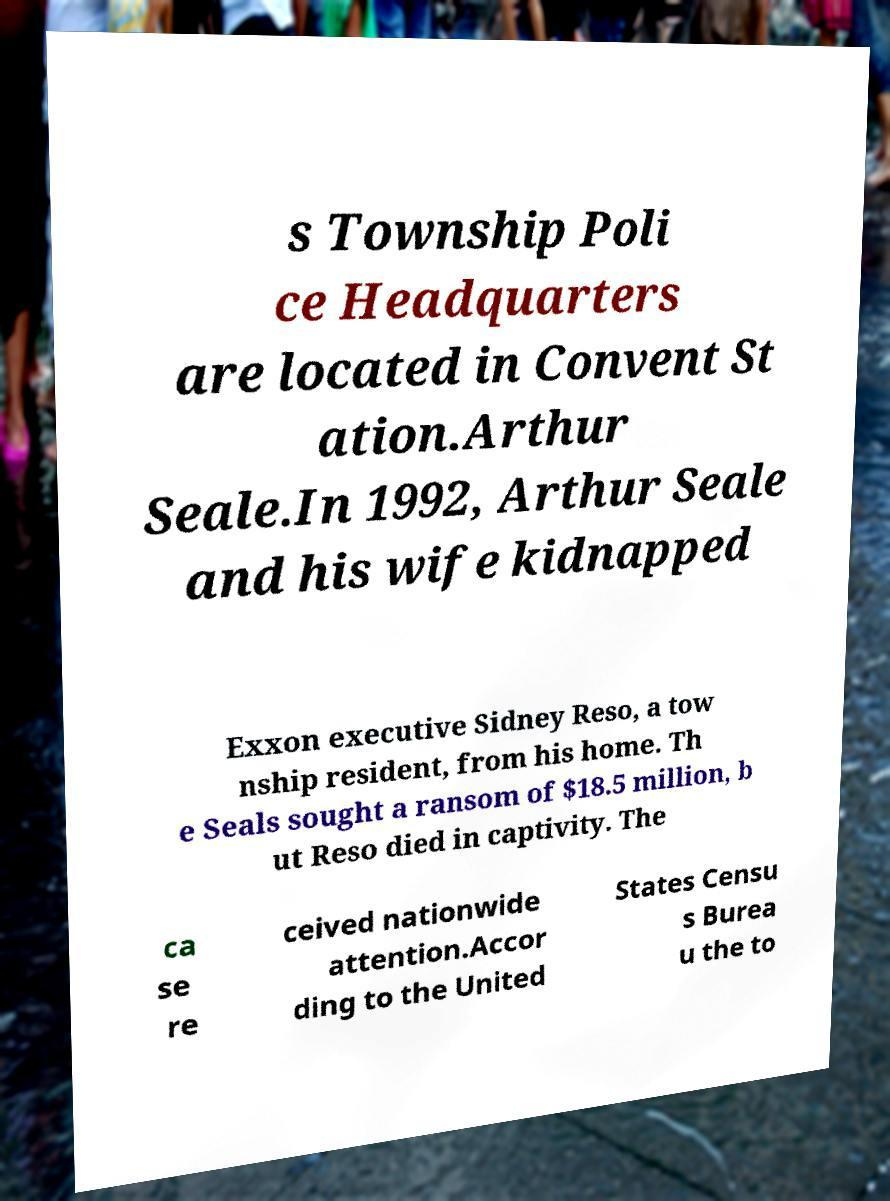Please read and relay the text visible in this image. What does it say? s Township Poli ce Headquarters are located in Convent St ation.Arthur Seale.In 1992, Arthur Seale and his wife kidnapped Exxon executive Sidney Reso, a tow nship resident, from his home. Th e Seals sought a ransom of $18.5 million, b ut Reso died in captivity. The ca se re ceived nationwide attention.Accor ding to the United States Censu s Burea u the to 